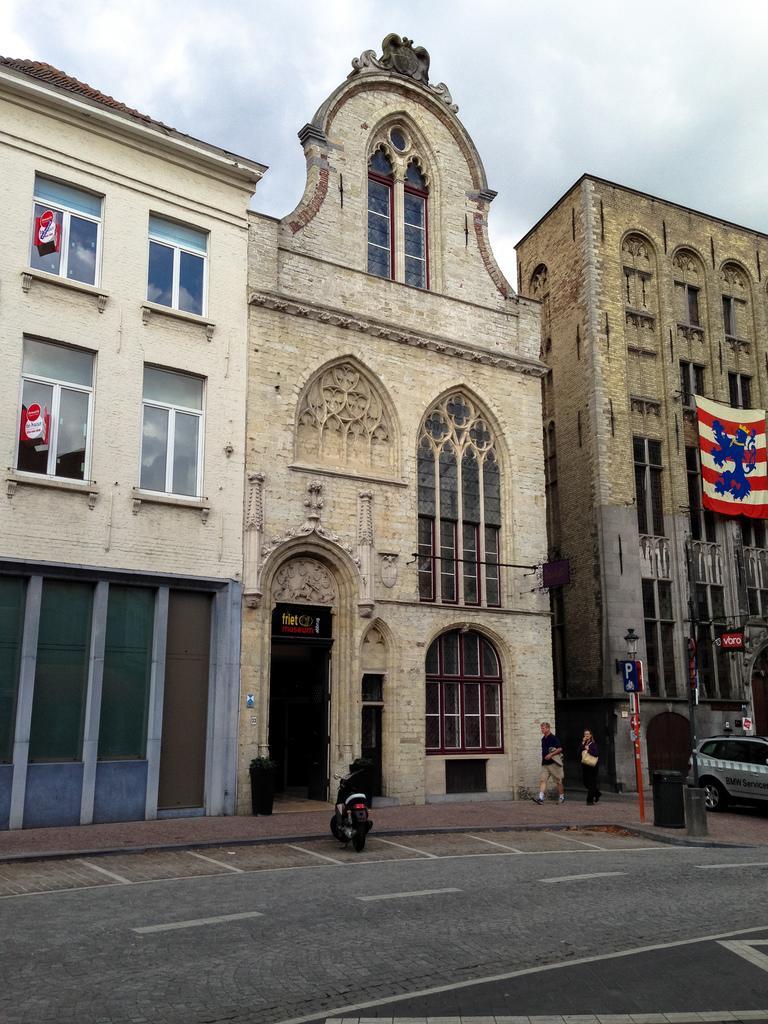In one or two sentences, can you explain what this image depicts? There is a road, vehicles, people and poles in the foreground area of the image, there are buildings, flag and the sky in the background. 